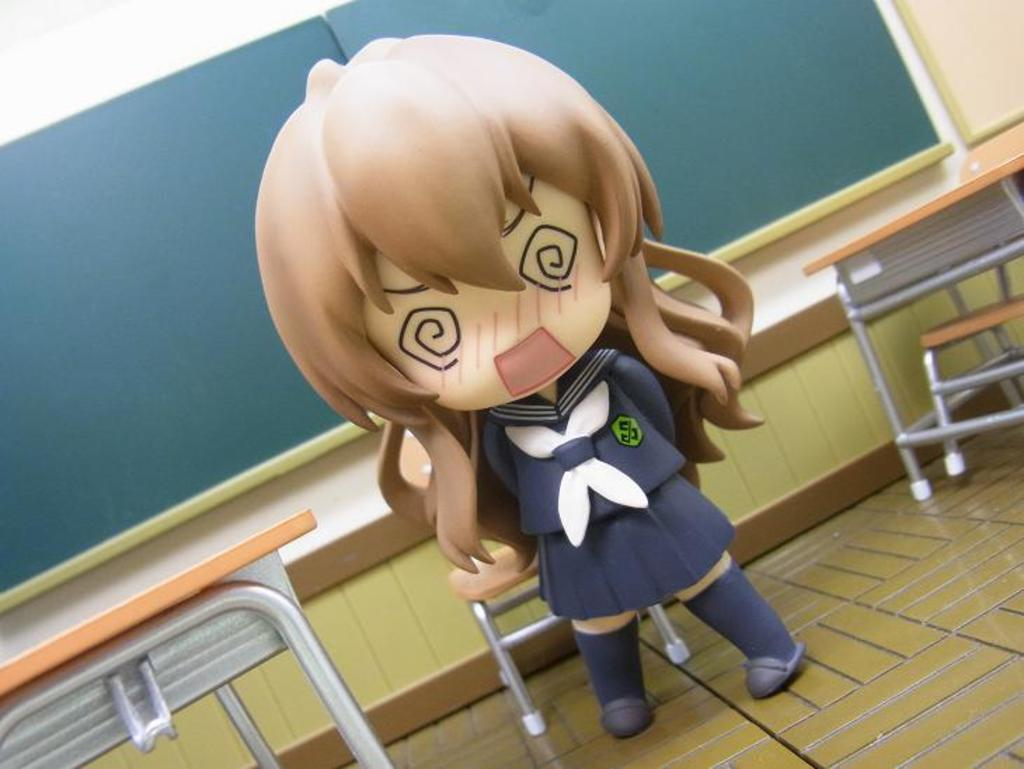What is the main object in the image? There is a doll in the image. What type of furniture is present in the image? There are tables and chairs in the image. What can be seen on the wall in the background of the image? There are boards on the wall in the background of the image. What type of stone can be seen on the playground in the image? There is no playground or stone present in the image. 